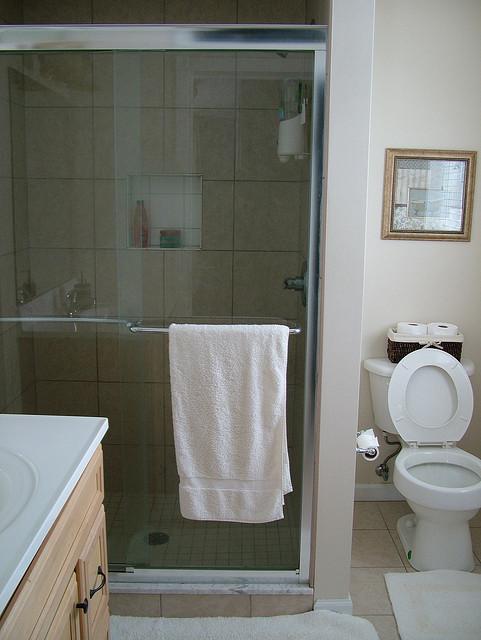How many toilet paper rolls are visible?
Concise answer only. 3. What is on the back wall?
Write a very short answer. Picture. Is there a towel hanging in the bathroom?
Keep it brief. Yes. What is seen in shadow?
Short answer required. Shower. Are these wooden doors?
Give a very brief answer. No. Is the toilet seat up?
Be succinct. Yes. What position is the toilet lid?
Be succinct. Up. What color is the shower?
Short answer required. Beige. Is there kleenex in the box?
Be succinct. No. What is the correct term for the blue and clear item hanging in the shower  on the wall?
Quick response, please. Soap. 